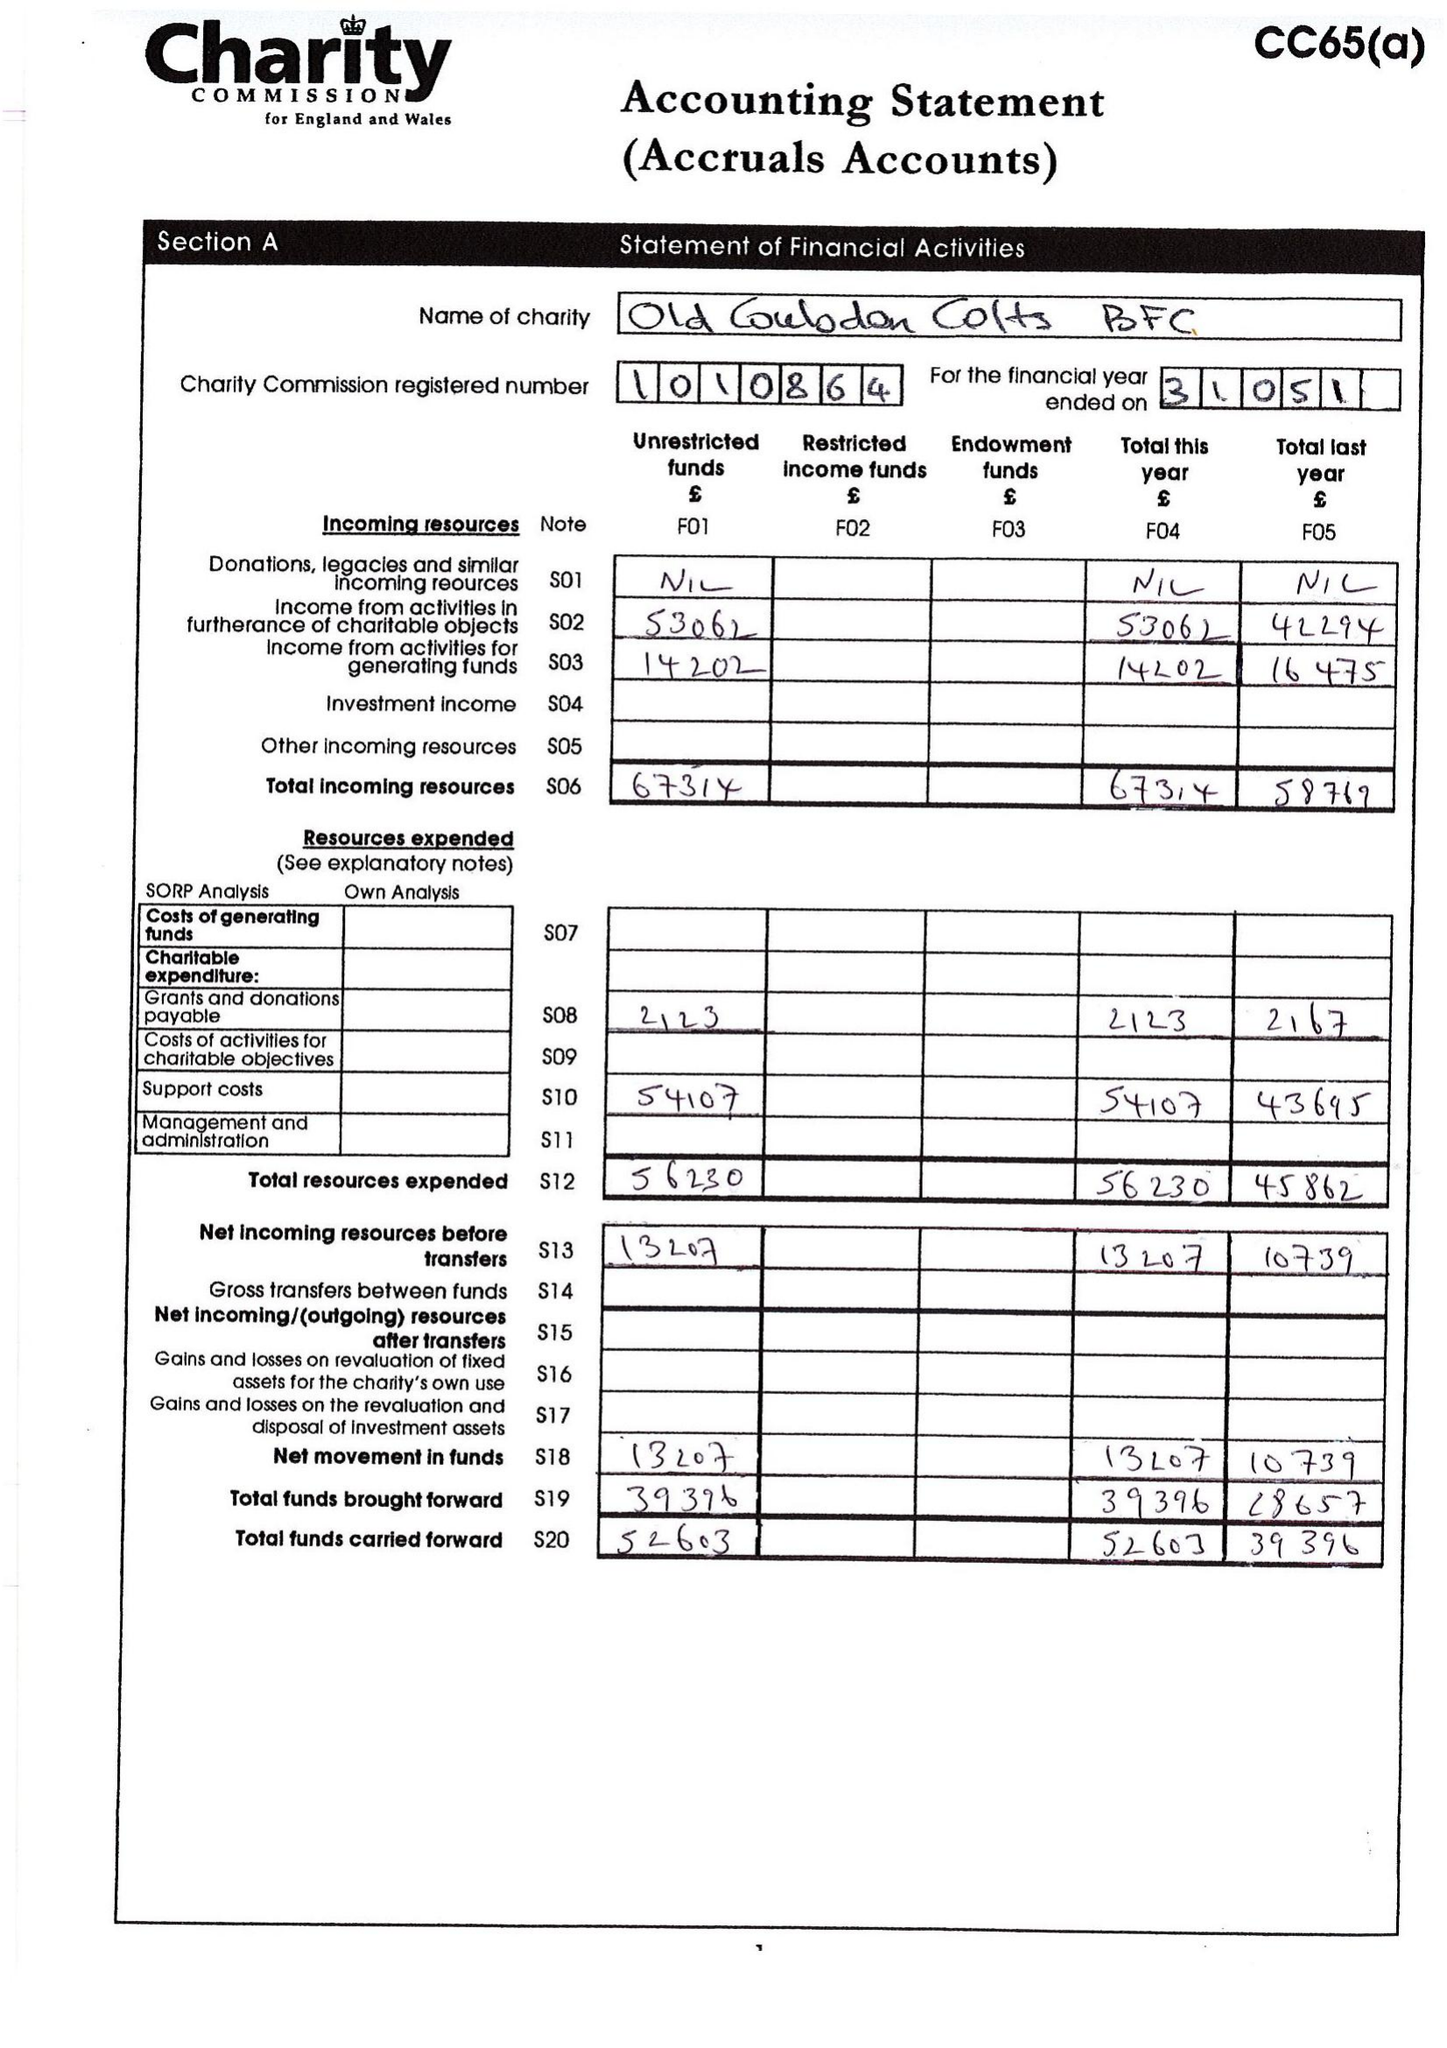What is the value for the spending_annually_in_british_pounds?
Answer the question using a single word or phrase. 56230.24 